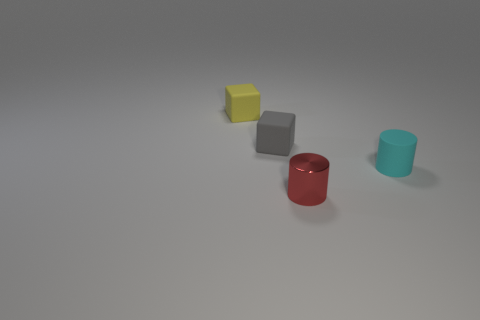There is a object that is to the right of the red thing; what is its shape?
Ensure brevity in your answer.  Cylinder. What is the color of the tiny rubber cylinder?
Your answer should be compact. Cyan. What color is the cylinder that is made of the same material as the small gray block?
Give a very brief answer. Cyan. How many big brown blocks have the same material as the gray cube?
Offer a very short reply. 0. What number of gray cubes are to the right of the small gray rubber block?
Your answer should be very brief. 0. Does the small cylinder in front of the cyan rubber cylinder have the same material as the tiny cylinder that is behind the red metallic object?
Make the answer very short. No. Are there more tiny matte blocks that are in front of the small yellow thing than matte things left of the matte cylinder?
Your answer should be very brief. No. What is the material of the tiny thing that is both to the right of the tiny yellow object and behind the small cyan matte cylinder?
Make the answer very short. Rubber. Does the small cyan thing have the same material as the object in front of the cyan object?
Your answer should be compact. No. How many things are either small yellow metallic objects or small red cylinders that are in front of the cyan matte cylinder?
Your answer should be compact. 1. 